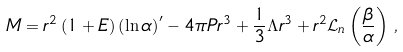Convert formula to latex. <formula><loc_0><loc_0><loc_500><loc_500>M & = r ^ { 2 } \left ( 1 + E \right ) \left ( \ln \alpha \right ) ^ { \prime } - 4 \pi P r ^ { 3 } + \frac { 1 } { 3 } \Lambda r ^ { 3 } + r ^ { 2 } \mathcal { L } _ { n } \left ( \frac { \beta } { \alpha } \right ) \, ,</formula> 